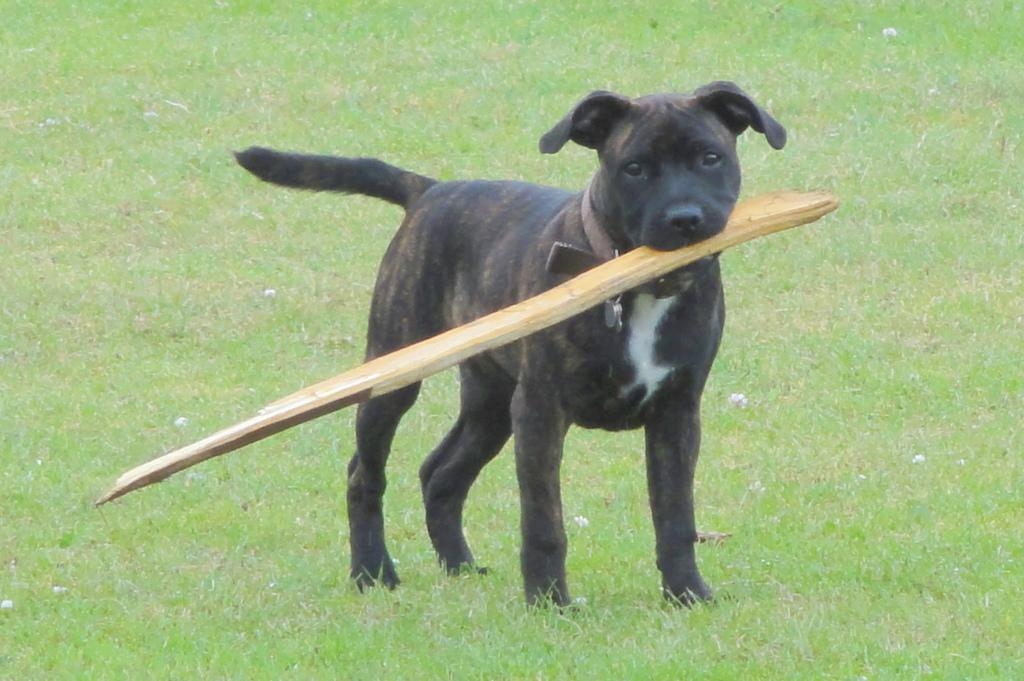What type of animal is in the image? There is a black dog in the image. What is the dog holding in its mouth? The dog is holding a wooden stick in its mouth. What can be seen in the background of the image? There is grass visible in the background of the image. How many fangs can be seen on the dog's rock in the image? There is no rock or fangs visible in the image; it features a black dog holding a wooden stick. 